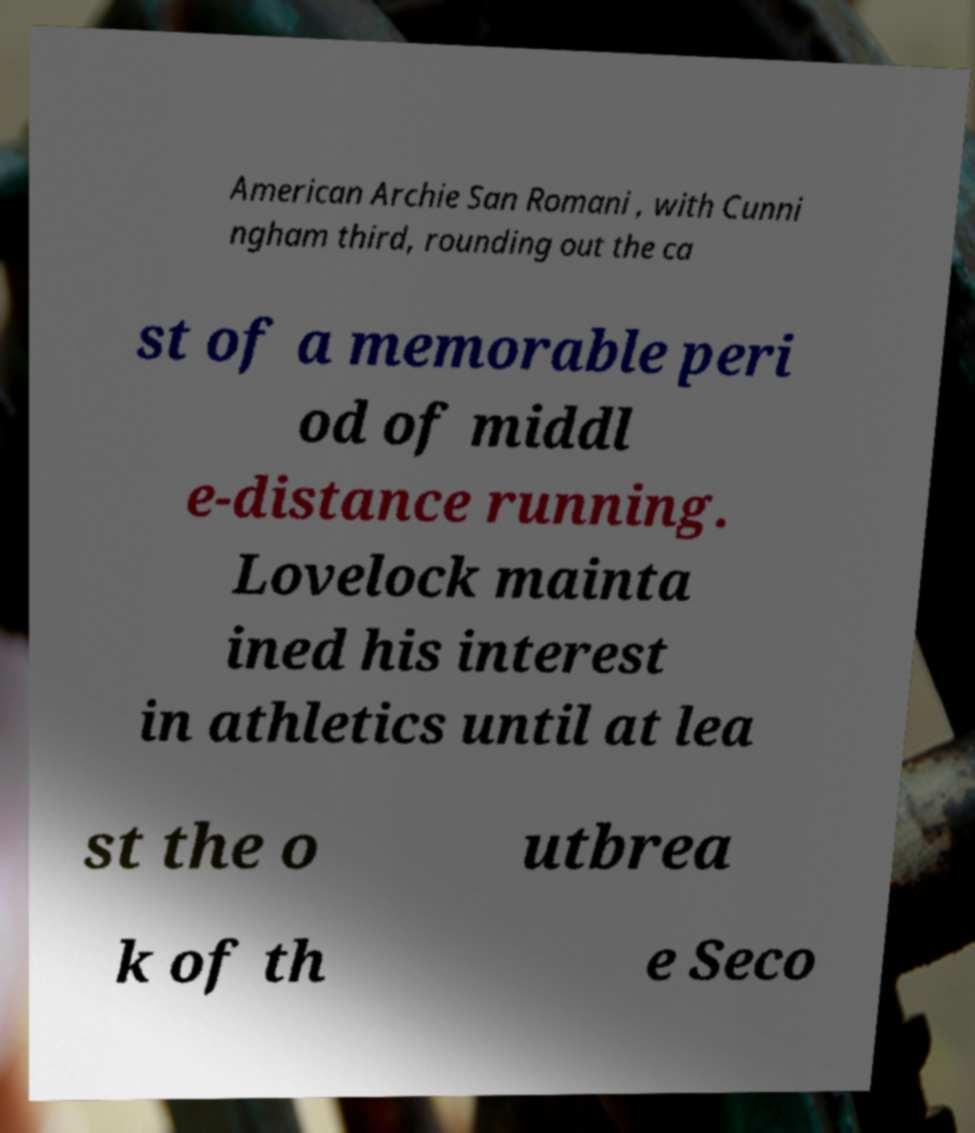Please identify and transcribe the text found in this image. American Archie San Romani , with Cunni ngham third, rounding out the ca st of a memorable peri od of middl e-distance running. Lovelock mainta ined his interest in athletics until at lea st the o utbrea k of th e Seco 